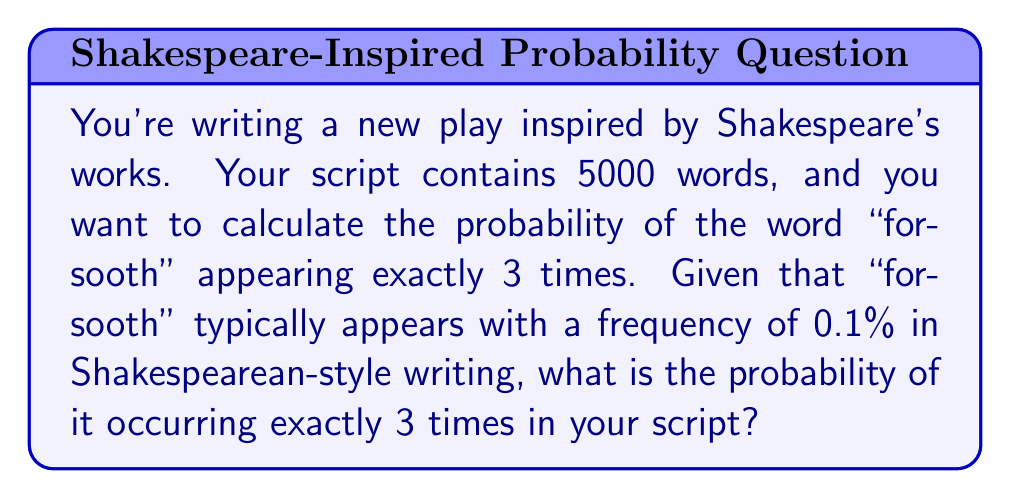Can you answer this question? To solve this problem, we'll use the Binomial Probability Distribution, as we're dealing with a fixed number of independent trials (words) and a constant probability of success (the word "forsooth" appearing).

1. Let's define our variables:
   $n = 5000$ (total number of words)
   $k = 3$ (exact number of times "forsooth" appears)
   $p = 0.001$ (probability of "forsooth" appearing, given as 0.1%)

2. The Binomial Probability formula is:

   $$P(X = k) = \binom{n}{k} p^k (1-p)^{n-k}$$

3. Calculate the binomial coefficient:
   $$\binom{5000}{3} = \frac{5000!}{3!(5000-3)!} = 20,833,750,000$$

4. Now, let's substitute all values into the formula:

   $$P(X = 3) = 20,833,750,000 \cdot (0.001)^3 \cdot (0.999)^{4997}$$

5. Simplify:
   $$P(X = 3) = 20,833,750,000 \cdot 0.000000001 \cdot 0.007399$$
   $$P(X = 3) \approx 0.1542$$

6. Convert to percentage:
   $$0.1542 \cdot 100\% \approx 15.42\%$$

Thus, the probability of the word "forsooth" appearing exactly 3 times in your 5000-word script is approximately 15.42%.
Answer: 15.42% 